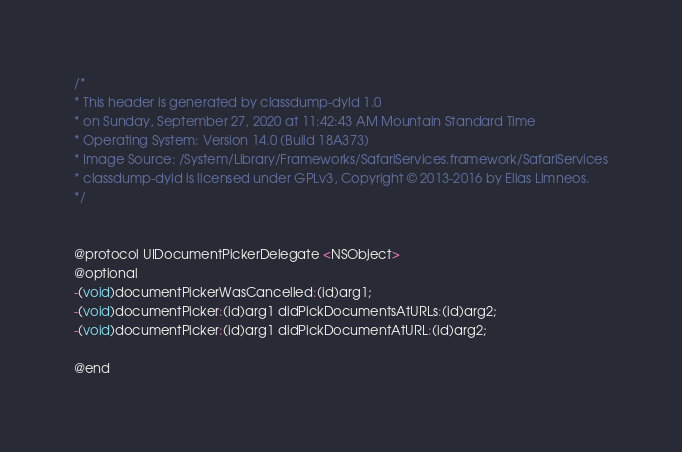Convert code to text. <code><loc_0><loc_0><loc_500><loc_500><_C_>/*
* This header is generated by classdump-dyld 1.0
* on Sunday, September 27, 2020 at 11:42:43 AM Mountain Standard Time
* Operating System: Version 14.0 (Build 18A373)
* Image Source: /System/Library/Frameworks/SafariServices.framework/SafariServices
* classdump-dyld is licensed under GPLv3, Copyright © 2013-2016 by Elias Limneos.
*/


@protocol UIDocumentPickerDelegate <NSObject>
@optional
-(void)documentPickerWasCancelled:(id)arg1;
-(void)documentPicker:(id)arg1 didPickDocumentsAtURLs:(id)arg2;
-(void)documentPicker:(id)arg1 didPickDocumentAtURL:(id)arg2;

@end

</code> 